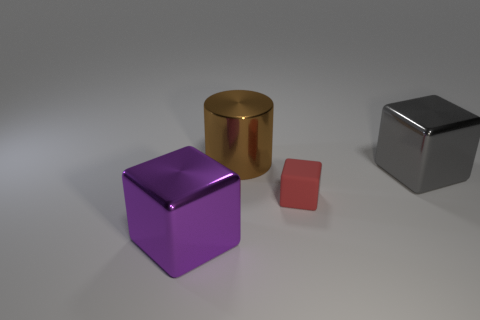Subtract all metallic blocks. How many blocks are left? 1 Add 3 big brown metallic cylinders. How many objects exist? 7 Subtract all big purple matte cubes. Subtract all large gray blocks. How many objects are left? 3 Add 3 big purple shiny cubes. How many big purple shiny cubes are left? 4 Add 2 red things. How many red things exist? 3 Subtract 0 brown cubes. How many objects are left? 4 Subtract all blocks. How many objects are left? 1 Subtract all yellow blocks. Subtract all yellow cylinders. How many blocks are left? 3 